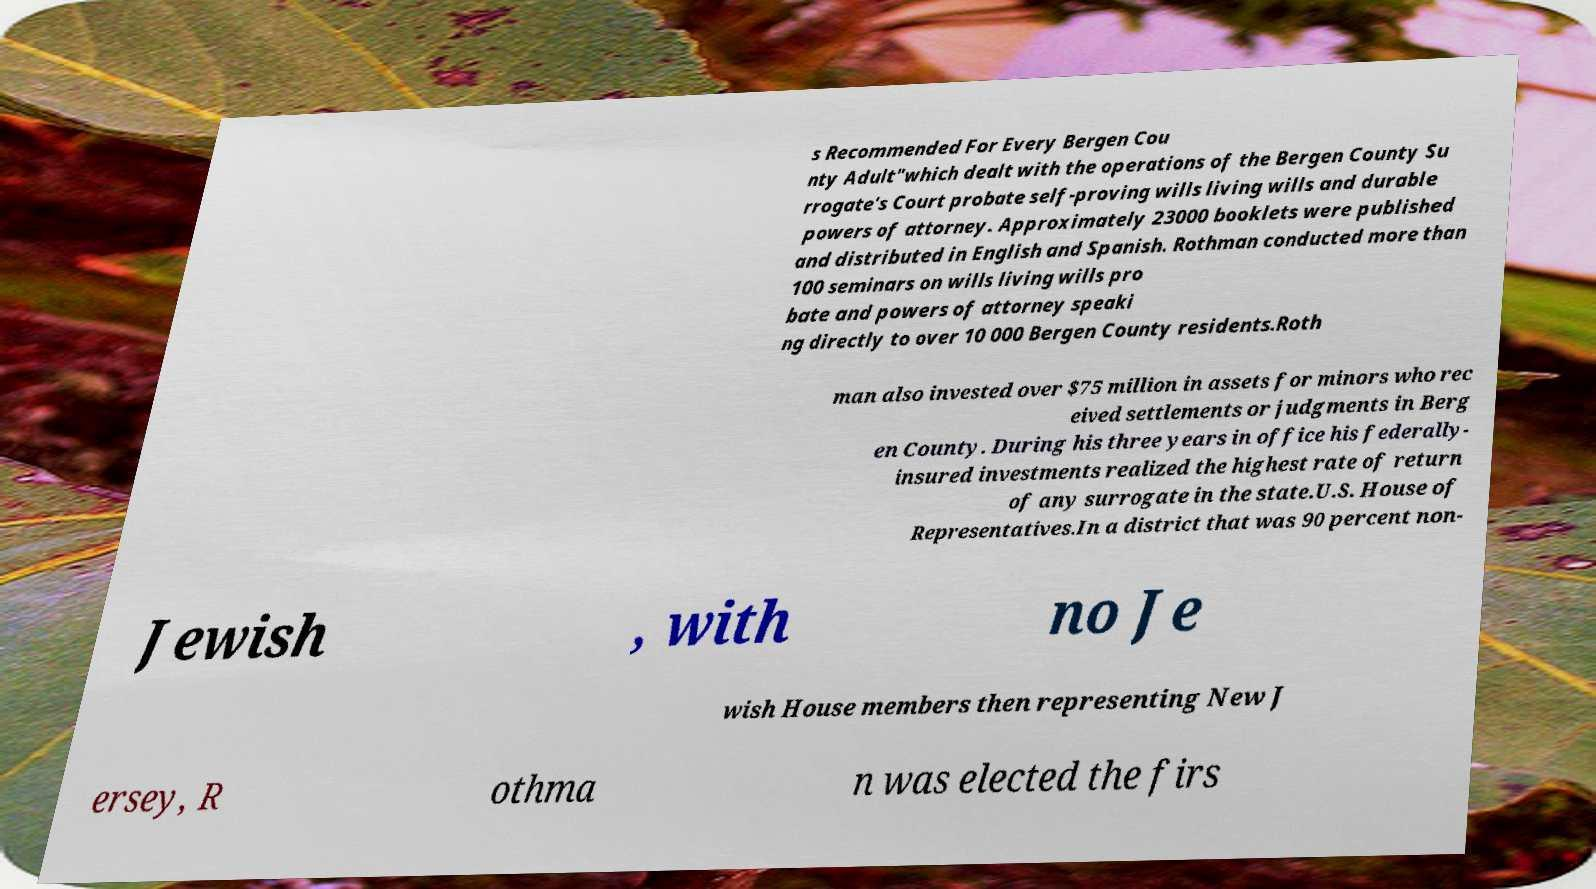What messages or text are displayed in this image? I need them in a readable, typed format. s Recommended For Every Bergen Cou nty Adult"which dealt with the operations of the Bergen County Su rrogate's Court probate self-proving wills living wills and durable powers of attorney. Approximately 23000 booklets were published and distributed in English and Spanish. Rothman conducted more than 100 seminars on wills living wills pro bate and powers of attorney speaki ng directly to over 10 000 Bergen County residents.Roth man also invested over $75 million in assets for minors who rec eived settlements or judgments in Berg en County. During his three years in office his federally- insured investments realized the highest rate of return of any surrogate in the state.U.S. House of Representatives.In a district that was 90 percent non- Jewish , with no Je wish House members then representing New J ersey, R othma n was elected the firs 